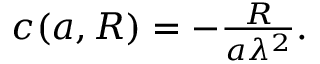Convert formula to latex. <formula><loc_0><loc_0><loc_500><loc_500>\begin{array} { r } { c ( { a } , R ) = - \frac { R } { { a } \lambda ^ { 2 } } . } \end{array}</formula> 